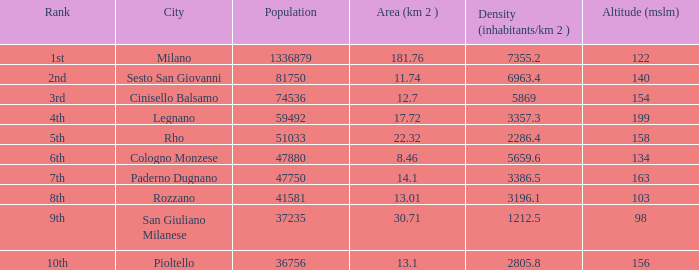Among populations with a density greater than 2805.8 inhabitants/km², a rank of 1st, and an altitude less than 122 meters, which one has the highest population? None. 